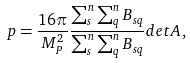<formula> <loc_0><loc_0><loc_500><loc_500>p = \frac { 1 6 \pi } { M _ { P } ^ { 2 } } \frac { \sum _ { s } ^ { n } \sum _ { q } ^ { n } B _ { s q } } { \sum _ { s } ^ { n } \sum _ { q } ^ { n } B _ { s q } } { d e t A } \, ,</formula> 